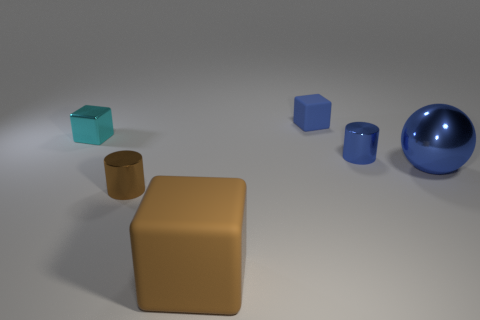Add 2 cyan shiny blocks. How many objects exist? 8 Subtract all cylinders. How many objects are left? 4 Subtract all tiny cylinders. Subtract all brown objects. How many objects are left? 2 Add 3 brown matte blocks. How many brown matte blocks are left? 4 Add 3 blue rubber objects. How many blue rubber objects exist? 4 Subtract 0 red balls. How many objects are left? 6 